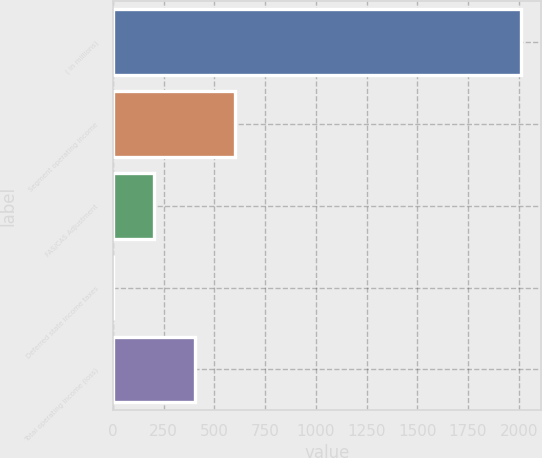Convert chart to OTSL. <chart><loc_0><loc_0><loc_500><loc_500><bar_chart><fcel>( in millions)<fcel>Segment operating income<fcel>FAS/CAS Adjustment<fcel>Deferred state income taxes<fcel>Total operating income (loss)<nl><fcel>2011<fcel>604<fcel>202<fcel>1<fcel>403<nl></chart> 